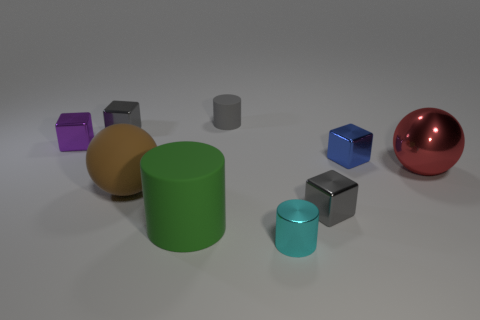There is a matte cylinder in front of the small thing behind the gray shiny block left of the large green rubber object; how big is it?
Keep it short and to the point. Large. What is the size of the red object that is the same material as the tiny purple object?
Keep it short and to the point. Large. The object that is both in front of the blue cube and to the left of the green matte cylinder is what color?
Offer a very short reply. Brown. Do the gray metallic object that is right of the green thing and the small purple metallic object behind the big red shiny object have the same shape?
Your answer should be very brief. Yes. There is a cube in front of the metal ball; what material is it?
Your answer should be compact. Metal. How many objects are either gray blocks to the right of the cyan cylinder or big gray balls?
Provide a short and direct response. 1. Are there the same number of green cylinders that are on the left side of the large brown rubber thing and yellow matte things?
Your answer should be very brief. Yes. Does the blue block have the same size as the gray matte cylinder?
Ensure brevity in your answer.  Yes. What color is the matte cylinder that is the same size as the purple metal thing?
Ensure brevity in your answer.  Gray. There is a blue thing; does it have the same size as the rubber cylinder that is in front of the purple cube?
Give a very brief answer. No. 